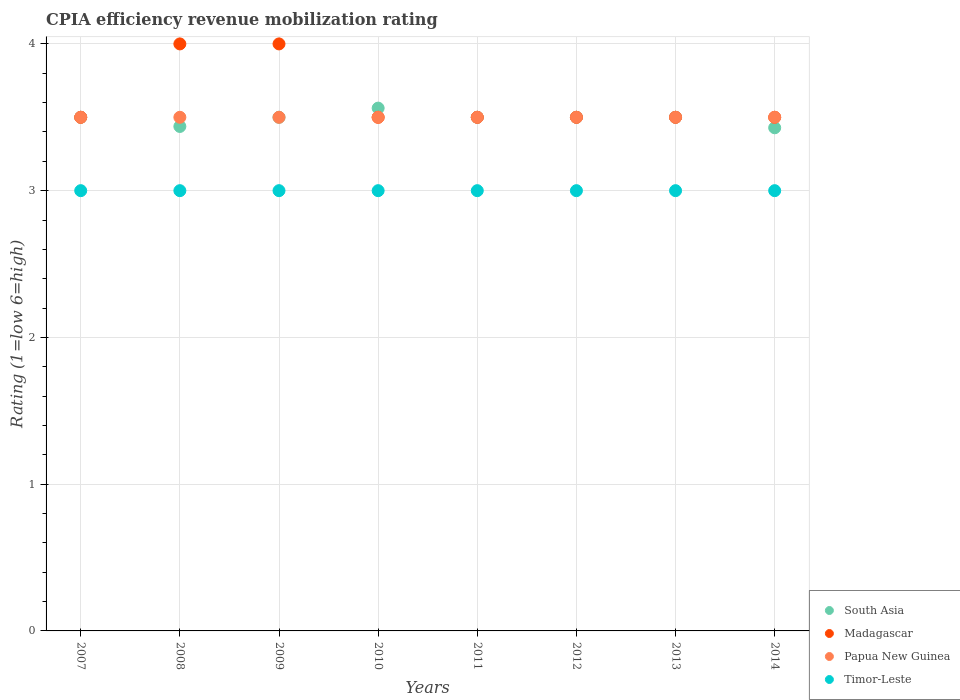What is the CPIA rating in Madagascar in 2010?
Offer a very short reply. 3.5. Across all years, what is the maximum CPIA rating in Timor-Leste?
Provide a short and direct response. 3. What is the total CPIA rating in South Asia in the graph?
Ensure brevity in your answer.  27.93. What is the difference between the CPIA rating in Madagascar in 2013 and the CPIA rating in Papua New Guinea in 2014?
Provide a short and direct response. 0. What is the average CPIA rating in Timor-Leste per year?
Your answer should be compact. 3. In how many years, is the CPIA rating in Timor-Leste greater than 1.6?
Give a very brief answer. 8. What is the ratio of the CPIA rating in South Asia in 2010 to that in 2014?
Your answer should be compact. 1.04. Is the CPIA rating in Papua New Guinea in 2007 less than that in 2010?
Your answer should be very brief. No. Is the difference between the CPIA rating in Papua New Guinea in 2009 and 2011 greater than the difference between the CPIA rating in Timor-Leste in 2009 and 2011?
Your answer should be very brief. No. What is the difference between the highest and the lowest CPIA rating in Madagascar?
Ensure brevity in your answer.  0.5. In how many years, is the CPIA rating in Timor-Leste greater than the average CPIA rating in Timor-Leste taken over all years?
Ensure brevity in your answer.  0. Is it the case that in every year, the sum of the CPIA rating in Papua New Guinea and CPIA rating in Madagascar  is greater than the sum of CPIA rating in South Asia and CPIA rating in Timor-Leste?
Keep it short and to the point. Yes. Is the CPIA rating in South Asia strictly less than the CPIA rating in Madagascar over the years?
Keep it short and to the point. No. How many dotlines are there?
Offer a terse response. 4. Does the graph contain grids?
Your answer should be very brief. Yes. How many legend labels are there?
Provide a succinct answer. 4. What is the title of the graph?
Offer a very short reply. CPIA efficiency revenue mobilization rating. What is the label or title of the X-axis?
Provide a short and direct response. Years. What is the Rating (1=low 6=high) in Papua New Guinea in 2007?
Your answer should be compact. 3.5. What is the Rating (1=low 6=high) in South Asia in 2008?
Offer a terse response. 3.44. What is the Rating (1=low 6=high) in Madagascar in 2008?
Provide a succinct answer. 4. What is the Rating (1=low 6=high) of South Asia in 2010?
Keep it short and to the point. 3.56. What is the Rating (1=low 6=high) in Timor-Leste in 2010?
Ensure brevity in your answer.  3. What is the Rating (1=low 6=high) in South Asia in 2011?
Make the answer very short. 3.5. What is the Rating (1=low 6=high) in Madagascar in 2011?
Make the answer very short. 3.5. What is the Rating (1=low 6=high) of Papua New Guinea in 2011?
Your answer should be very brief. 3.5. What is the Rating (1=low 6=high) in Timor-Leste in 2011?
Ensure brevity in your answer.  3. What is the Rating (1=low 6=high) of South Asia in 2012?
Offer a very short reply. 3.5. What is the Rating (1=low 6=high) of Papua New Guinea in 2012?
Give a very brief answer. 3.5. What is the Rating (1=low 6=high) of Timor-Leste in 2012?
Offer a terse response. 3. What is the Rating (1=low 6=high) of South Asia in 2013?
Ensure brevity in your answer.  3.5. What is the Rating (1=low 6=high) in Timor-Leste in 2013?
Your answer should be compact. 3. What is the Rating (1=low 6=high) in South Asia in 2014?
Provide a succinct answer. 3.43. What is the Rating (1=low 6=high) in Papua New Guinea in 2014?
Your answer should be very brief. 3.5. Across all years, what is the maximum Rating (1=low 6=high) of South Asia?
Keep it short and to the point. 3.56. Across all years, what is the minimum Rating (1=low 6=high) of South Asia?
Provide a short and direct response. 3.43. Across all years, what is the minimum Rating (1=low 6=high) of Papua New Guinea?
Provide a succinct answer. 3.5. What is the total Rating (1=low 6=high) of South Asia in the graph?
Keep it short and to the point. 27.93. What is the total Rating (1=low 6=high) in Papua New Guinea in the graph?
Provide a succinct answer. 28. What is the difference between the Rating (1=low 6=high) in South Asia in 2007 and that in 2008?
Provide a short and direct response. 0.06. What is the difference between the Rating (1=low 6=high) in Madagascar in 2007 and that in 2008?
Make the answer very short. -0.5. What is the difference between the Rating (1=low 6=high) of Timor-Leste in 2007 and that in 2008?
Provide a succinct answer. 0. What is the difference between the Rating (1=low 6=high) of Madagascar in 2007 and that in 2009?
Your response must be concise. -0.5. What is the difference between the Rating (1=low 6=high) of Papua New Guinea in 2007 and that in 2009?
Your answer should be very brief. 0. What is the difference between the Rating (1=low 6=high) in Timor-Leste in 2007 and that in 2009?
Make the answer very short. 0. What is the difference between the Rating (1=low 6=high) of South Asia in 2007 and that in 2010?
Your response must be concise. -0.06. What is the difference between the Rating (1=low 6=high) in Madagascar in 2007 and that in 2010?
Provide a succinct answer. 0. What is the difference between the Rating (1=low 6=high) in South Asia in 2007 and that in 2011?
Keep it short and to the point. 0. What is the difference between the Rating (1=low 6=high) in Madagascar in 2007 and that in 2011?
Give a very brief answer. 0. What is the difference between the Rating (1=low 6=high) in Madagascar in 2007 and that in 2012?
Keep it short and to the point. 0. What is the difference between the Rating (1=low 6=high) of Timor-Leste in 2007 and that in 2012?
Your answer should be compact. 0. What is the difference between the Rating (1=low 6=high) of Papua New Guinea in 2007 and that in 2013?
Offer a terse response. 0. What is the difference between the Rating (1=low 6=high) of Timor-Leste in 2007 and that in 2013?
Offer a terse response. 0. What is the difference between the Rating (1=low 6=high) in South Asia in 2007 and that in 2014?
Give a very brief answer. 0.07. What is the difference between the Rating (1=low 6=high) in Papua New Guinea in 2007 and that in 2014?
Your answer should be very brief. 0. What is the difference between the Rating (1=low 6=high) of South Asia in 2008 and that in 2009?
Your answer should be very brief. -0.06. What is the difference between the Rating (1=low 6=high) of Madagascar in 2008 and that in 2009?
Offer a very short reply. 0. What is the difference between the Rating (1=low 6=high) of South Asia in 2008 and that in 2010?
Provide a succinct answer. -0.12. What is the difference between the Rating (1=low 6=high) in Madagascar in 2008 and that in 2010?
Provide a succinct answer. 0.5. What is the difference between the Rating (1=low 6=high) of South Asia in 2008 and that in 2011?
Your answer should be compact. -0.06. What is the difference between the Rating (1=low 6=high) in Madagascar in 2008 and that in 2011?
Make the answer very short. 0.5. What is the difference between the Rating (1=low 6=high) in Papua New Guinea in 2008 and that in 2011?
Give a very brief answer. 0. What is the difference between the Rating (1=low 6=high) in South Asia in 2008 and that in 2012?
Make the answer very short. -0.06. What is the difference between the Rating (1=low 6=high) of Papua New Guinea in 2008 and that in 2012?
Provide a short and direct response. 0. What is the difference between the Rating (1=low 6=high) in South Asia in 2008 and that in 2013?
Your answer should be compact. -0.06. What is the difference between the Rating (1=low 6=high) in Papua New Guinea in 2008 and that in 2013?
Ensure brevity in your answer.  0. What is the difference between the Rating (1=low 6=high) of South Asia in 2008 and that in 2014?
Provide a short and direct response. 0.01. What is the difference between the Rating (1=low 6=high) in Madagascar in 2008 and that in 2014?
Offer a terse response. 0.5. What is the difference between the Rating (1=low 6=high) of Papua New Guinea in 2008 and that in 2014?
Offer a very short reply. 0. What is the difference between the Rating (1=low 6=high) of South Asia in 2009 and that in 2010?
Make the answer very short. -0.06. What is the difference between the Rating (1=low 6=high) in Madagascar in 2009 and that in 2010?
Offer a very short reply. 0.5. What is the difference between the Rating (1=low 6=high) in Madagascar in 2009 and that in 2011?
Provide a short and direct response. 0.5. What is the difference between the Rating (1=low 6=high) in Papua New Guinea in 2009 and that in 2012?
Make the answer very short. 0. What is the difference between the Rating (1=low 6=high) of Madagascar in 2009 and that in 2013?
Offer a very short reply. 0.5. What is the difference between the Rating (1=low 6=high) in Timor-Leste in 2009 and that in 2013?
Your answer should be very brief. 0. What is the difference between the Rating (1=low 6=high) in South Asia in 2009 and that in 2014?
Provide a succinct answer. 0.07. What is the difference between the Rating (1=low 6=high) of Madagascar in 2009 and that in 2014?
Your answer should be compact. 0.5. What is the difference between the Rating (1=low 6=high) of Papua New Guinea in 2009 and that in 2014?
Make the answer very short. 0. What is the difference between the Rating (1=low 6=high) of South Asia in 2010 and that in 2011?
Keep it short and to the point. 0.06. What is the difference between the Rating (1=low 6=high) in South Asia in 2010 and that in 2012?
Provide a short and direct response. 0.06. What is the difference between the Rating (1=low 6=high) of Madagascar in 2010 and that in 2012?
Offer a very short reply. 0. What is the difference between the Rating (1=low 6=high) of Timor-Leste in 2010 and that in 2012?
Your answer should be very brief. 0. What is the difference between the Rating (1=low 6=high) of South Asia in 2010 and that in 2013?
Give a very brief answer. 0.06. What is the difference between the Rating (1=low 6=high) in South Asia in 2010 and that in 2014?
Keep it short and to the point. 0.13. What is the difference between the Rating (1=low 6=high) of Papua New Guinea in 2010 and that in 2014?
Provide a short and direct response. 0. What is the difference between the Rating (1=low 6=high) in Timor-Leste in 2010 and that in 2014?
Provide a succinct answer. 0. What is the difference between the Rating (1=low 6=high) in Madagascar in 2011 and that in 2012?
Your answer should be compact. 0. What is the difference between the Rating (1=low 6=high) of Papua New Guinea in 2011 and that in 2012?
Provide a short and direct response. 0. What is the difference between the Rating (1=low 6=high) of Madagascar in 2011 and that in 2013?
Ensure brevity in your answer.  0. What is the difference between the Rating (1=low 6=high) in Timor-Leste in 2011 and that in 2013?
Offer a terse response. 0. What is the difference between the Rating (1=low 6=high) in South Asia in 2011 and that in 2014?
Provide a short and direct response. 0.07. What is the difference between the Rating (1=low 6=high) of Timor-Leste in 2011 and that in 2014?
Keep it short and to the point. 0. What is the difference between the Rating (1=low 6=high) in South Asia in 2012 and that in 2013?
Ensure brevity in your answer.  0. What is the difference between the Rating (1=low 6=high) in Madagascar in 2012 and that in 2013?
Offer a very short reply. 0. What is the difference between the Rating (1=low 6=high) of Papua New Guinea in 2012 and that in 2013?
Keep it short and to the point. 0. What is the difference between the Rating (1=low 6=high) in Timor-Leste in 2012 and that in 2013?
Make the answer very short. 0. What is the difference between the Rating (1=low 6=high) in South Asia in 2012 and that in 2014?
Your answer should be very brief. 0.07. What is the difference between the Rating (1=low 6=high) in Papua New Guinea in 2012 and that in 2014?
Your answer should be very brief. 0. What is the difference between the Rating (1=low 6=high) of Timor-Leste in 2012 and that in 2014?
Your answer should be very brief. 0. What is the difference between the Rating (1=low 6=high) in South Asia in 2013 and that in 2014?
Offer a very short reply. 0.07. What is the difference between the Rating (1=low 6=high) in Timor-Leste in 2013 and that in 2014?
Offer a terse response. 0. What is the difference between the Rating (1=low 6=high) in South Asia in 2007 and the Rating (1=low 6=high) in Madagascar in 2008?
Your response must be concise. -0.5. What is the difference between the Rating (1=low 6=high) of Madagascar in 2007 and the Rating (1=low 6=high) of Timor-Leste in 2008?
Your response must be concise. 0.5. What is the difference between the Rating (1=low 6=high) of South Asia in 2007 and the Rating (1=low 6=high) of Timor-Leste in 2009?
Your response must be concise. 0.5. What is the difference between the Rating (1=low 6=high) of Madagascar in 2007 and the Rating (1=low 6=high) of Papua New Guinea in 2009?
Offer a very short reply. 0. What is the difference between the Rating (1=low 6=high) of Madagascar in 2007 and the Rating (1=low 6=high) of Timor-Leste in 2009?
Ensure brevity in your answer.  0.5. What is the difference between the Rating (1=low 6=high) in South Asia in 2007 and the Rating (1=low 6=high) in Madagascar in 2010?
Provide a succinct answer. 0. What is the difference between the Rating (1=low 6=high) in South Asia in 2007 and the Rating (1=low 6=high) in Timor-Leste in 2010?
Provide a short and direct response. 0.5. What is the difference between the Rating (1=low 6=high) of Madagascar in 2007 and the Rating (1=low 6=high) of Timor-Leste in 2010?
Keep it short and to the point. 0.5. What is the difference between the Rating (1=low 6=high) in Papua New Guinea in 2007 and the Rating (1=low 6=high) in Timor-Leste in 2010?
Offer a very short reply. 0.5. What is the difference between the Rating (1=low 6=high) in Madagascar in 2007 and the Rating (1=low 6=high) in Papua New Guinea in 2011?
Give a very brief answer. 0. What is the difference between the Rating (1=low 6=high) in Papua New Guinea in 2007 and the Rating (1=low 6=high) in Timor-Leste in 2011?
Give a very brief answer. 0.5. What is the difference between the Rating (1=low 6=high) in South Asia in 2007 and the Rating (1=low 6=high) in Timor-Leste in 2012?
Provide a short and direct response. 0.5. What is the difference between the Rating (1=low 6=high) in Madagascar in 2007 and the Rating (1=low 6=high) in Papua New Guinea in 2012?
Your answer should be compact. 0. What is the difference between the Rating (1=low 6=high) in Madagascar in 2007 and the Rating (1=low 6=high) in Timor-Leste in 2012?
Your answer should be compact. 0.5. What is the difference between the Rating (1=low 6=high) of Papua New Guinea in 2007 and the Rating (1=low 6=high) of Timor-Leste in 2012?
Provide a short and direct response. 0.5. What is the difference between the Rating (1=low 6=high) of South Asia in 2007 and the Rating (1=low 6=high) of Papua New Guinea in 2013?
Your response must be concise. 0. What is the difference between the Rating (1=low 6=high) of Madagascar in 2007 and the Rating (1=low 6=high) of Papua New Guinea in 2013?
Ensure brevity in your answer.  0. What is the difference between the Rating (1=low 6=high) of Papua New Guinea in 2007 and the Rating (1=low 6=high) of Timor-Leste in 2013?
Provide a succinct answer. 0.5. What is the difference between the Rating (1=low 6=high) in South Asia in 2007 and the Rating (1=low 6=high) in Timor-Leste in 2014?
Ensure brevity in your answer.  0.5. What is the difference between the Rating (1=low 6=high) of Papua New Guinea in 2007 and the Rating (1=low 6=high) of Timor-Leste in 2014?
Provide a succinct answer. 0.5. What is the difference between the Rating (1=low 6=high) of South Asia in 2008 and the Rating (1=low 6=high) of Madagascar in 2009?
Ensure brevity in your answer.  -0.56. What is the difference between the Rating (1=low 6=high) of South Asia in 2008 and the Rating (1=low 6=high) of Papua New Guinea in 2009?
Provide a succinct answer. -0.06. What is the difference between the Rating (1=low 6=high) in South Asia in 2008 and the Rating (1=low 6=high) in Timor-Leste in 2009?
Give a very brief answer. 0.44. What is the difference between the Rating (1=low 6=high) in Madagascar in 2008 and the Rating (1=low 6=high) in Papua New Guinea in 2009?
Your response must be concise. 0.5. What is the difference between the Rating (1=low 6=high) of Madagascar in 2008 and the Rating (1=low 6=high) of Timor-Leste in 2009?
Your answer should be compact. 1. What is the difference between the Rating (1=low 6=high) in Papua New Guinea in 2008 and the Rating (1=low 6=high) in Timor-Leste in 2009?
Your answer should be very brief. 0.5. What is the difference between the Rating (1=low 6=high) of South Asia in 2008 and the Rating (1=low 6=high) of Madagascar in 2010?
Your answer should be very brief. -0.06. What is the difference between the Rating (1=low 6=high) in South Asia in 2008 and the Rating (1=low 6=high) in Papua New Guinea in 2010?
Provide a short and direct response. -0.06. What is the difference between the Rating (1=low 6=high) of South Asia in 2008 and the Rating (1=low 6=high) of Timor-Leste in 2010?
Offer a terse response. 0.44. What is the difference between the Rating (1=low 6=high) of Papua New Guinea in 2008 and the Rating (1=low 6=high) of Timor-Leste in 2010?
Provide a succinct answer. 0.5. What is the difference between the Rating (1=low 6=high) in South Asia in 2008 and the Rating (1=low 6=high) in Madagascar in 2011?
Keep it short and to the point. -0.06. What is the difference between the Rating (1=low 6=high) in South Asia in 2008 and the Rating (1=low 6=high) in Papua New Guinea in 2011?
Your response must be concise. -0.06. What is the difference between the Rating (1=low 6=high) of South Asia in 2008 and the Rating (1=low 6=high) of Timor-Leste in 2011?
Your response must be concise. 0.44. What is the difference between the Rating (1=low 6=high) in Madagascar in 2008 and the Rating (1=low 6=high) in Timor-Leste in 2011?
Offer a terse response. 1. What is the difference between the Rating (1=low 6=high) of Papua New Guinea in 2008 and the Rating (1=low 6=high) of Timor-Leste in 2011?
Give a very brief answer. 0.5. What is the difference between the Rating (1=low 6=high) in South Asia in 2008 and the Rating (1=low 6=high) in Madagascar in 2012?
Keep it short and to the point. -0.06. What is the difference between the Rating (1=low 6=high) of South Asia in 2008 and the Rating (1=low 6=high) of Papua New Guinea in 2012?
Make the answer very short. -0.06. What is the difference between the Rating (1=low 6=high) in South Asia in 2008 and the Rating (1=low 6=high) in Timor-Leste in 2012?
Make the answer very short. 0.44. What is the difference between the Rating (1=low 6=high) in Madagascar in 2008 and the Rating (1=low 6=high) in Papua New Guinea in 2012?
Ensure brevity in your answer.  0.5. What is the difference between the Rating (1=low 6=high) of Madagascar in 2008 and the Rating (1=low 6=high) of Timor-Leste in 2012?
Make the answer very short. 1. What is the difference between the Rating (1=low 6=high) in South Asia in 2008 and the Rating (1=low 6=high) in Madagascar in 2013?
Offer a terse response. -0.06. What is the difference between the Rating (1=low 6=high) of South Asia in 2008 and the Rating (1=low 6=high) of Papua New Guinea in 2013?
Provide a succinct answer. -0.06. What is the difference between the Rating (1=low 6=high) of South Asia in 2008 and the Rating (1=low 6=high) of Timor-Leste in 2013?
Make the answer very short. 0.44. What is the difference between the Rating (1=low 6=high) in Madagascar in 2008 and the Rating (1=low 6=high) in Timor-Leste in 2013?
Your response must be concise. 1. What is the difference between the Rating (1=low 6=high) of Papua New Guinea in 2008 and the Rating (1=low 6=high) of Timor-Leste in 2013?
Your response must be concise. 0.5. What is the difference between the Rating (1=low 6=high) in South Asia in 2008 and the Rating (1=low 6=high) in Madagascar in 2014?
Offer a terse response. -0.06. What is the difference between the Rating (1=low 6=high) in South Asia in 2008 and the Rating (1=low 6=high) in Papua New Guinea in 2014?
Your answer should be very brief. -0.06. What is the difference between the Rating (1=low 6=high) in South Asia in 2008 and the Rating (1=low 6=high) in Timor-Leste in 2014?
Your response must be concise. 0.44. What is the difference between the Rating (1=low 6=high) in Madagascar in 2008 and the Rating (1=low 6=high) in Timor-Leste in 2014?
Make the answer very short. 1. What is the difference between the Rating (1=low 6=high) of Papua New Guinea in 2008 and the Rating (1=low 6=high) of Timor-Leste in 2014?
Provide a succinct answer. 0.5. What is the difference between the Rating (1=low 6=high) of South Asia in 2009 and the Rating (1=low 6=high) of Madagascar in 2010?
Your answer should be very brief. 0. What is the difference between the Rating (1=low 6=high) in Madagascar in 2009 and the Rating (1=low 6=high) in Papua New Guinea in 2010?
Your response must be concise. 0.5. What is the difference between the Rating (1=low 6=high) in Madagascar in 2009 and the Rating (1=low 6=high) in Timor-Leste in 2010?
Offer a terse response. 1. What is the difference between the Rating (1=low 6=high) in Papua New Guinea in 2009 and the Rating (1=low 6=high) in Timor-Leste in 2010?
Keep it short and to the point. 0.5. What is the difference between the Rating (1=low 6=high) of South Asia in 2009 and the Rating (1=low 6=high) of Madagascar in 2011?
Make the answer very short. 0. What is the difference between the Rating (1=low 6=high) in South Asia in 2009 and the Rating (1=low 6=high) in Papua New Guinea in 2011?
Provide a short and direct response. 0. What is the difference between the Rating (1=low 6=high) of South Asia in 2009 and the Rating (1=low 6=high) of Madagascar in 2012?
Provide a short and direct response. 0. What is the difference between the Rating (1=low 6=high) of South Asia in 2009 and the Rating (1=low 6=high) of Papua New Guinea in 2012?
Provide a short and direct response. 0. What is the difference between the Rating (1=low 6=high) in South Asia in 2009 and the Rating (1=low 6=high) in Timor-Leste in 2012?
Your answer should be very brief. 0.5. What is the difference between the Rating (1=low 6=high) in Madagascar in 2009 and the Rating (1=low 6=high) in Timor-Leste in 2012?
Offer a terse response. 1. What is the difference between the Rating (1=low 6=high) of South Asia in 2009 and the Rating (1=low 6=high) of Papua New Guinea in 2013?
Your response must be concise. 0. What is the difference between the Rating (1=low 6=high) of South Asia in 2009 and the Rating (1=low 6=high) of Timor-Leste in 2013?
Make the answer very short. 0.5. What is the difference between the Rating (1=low 6=high) of Madagascar in 2009 and the Rating (1=low 6=high) of Papua New Guinea in 2013?
Provide a short and direct response. 0.5. What is the difference between the Rating (1=low 6=high) in Papua New Guinea in 2009 and the Rating (1=low 6=high) in Timor-Leste in 2013?
Your answer should be compact. 0.5. What is the difference between the Rating (1=low 6=high) in South Asia in 2010 and the Rating (1=low 6=high) in Madagascar in 2011?
Your answer should be compact. 0.06. What is the difference between the Rating (1=low 6=high) of South Asia in 2010 and the Rating (1=low 6=high) of Papua New Guinea in 2011?
Give a very brief answer. 0.06. What is the difference between the Rating (1=low 6=high) of South Asia in 2010 and the Rating (1=low 6=high) of Timor-Leste in 2011?
Keep it short and to the point. 0.56. What is the difference between the Rating (1=low 6=high) of Madagascar in 2010 and the Rating (1=low 6=high) of Papua New Guinea in 2011?
Your response must be concise. 0. What is the difference between the Rating (1=low 6=high) in Madagascar in 2010 and the Rating (1=low 6=high) in Timor-Leste in 2011?
Make the answer very short. 0.5. What is the difference between the Rating (1=low 6=high) in South Asia in 2010 and the Rating (1=low 6=high) in Madagascar in 2012?
Offer a very short reply. 0.06. What is the difference between the Rating (1=low 6=high) of South Asia in 2010 and the Rating (1=low 6=high) of Papua New Guinea in 2012?
Offer a very short reply. 0.06. What is the difference between the Rating (1=low 6=high) in South Asia in 2010 and the Rating (1=low 6=high) in Timor-Leste in 2012?
Keep it short and to the point. 0.56. What is the difference between the Rating (1=low 6=high) in Madagascar in 2010 and the Rating (1=low 6=high) in Papua New Guinea in 2012?
Provide a short and direct response. 0. What is the difference between the Rating (1=low 6=high) of South Asia in 2010 and the Rating (1=low 6=high) of Madagascar in 2013?
Ensure brevity in your answer.  0.06. What is the difference between the Rating (1=low 6=high) of South Asia in 2010 and the Rating (1=low 6=high) of Papua New Guinea in 2013?
Offer a terse response. 0.06. What is the difference between the Rating (1=low 6=high) of South Asia in 2010 and the Rating (1=low 6=high) of Timor-Leste in 2013?
Your answer should be very brief. 0.56. What is the difference between the Rating (1=low 6=high) in Madagascar in 2010 and the Rating (1=low 6=high) in Timor-Leste in 2013?
Your response must be concise. 0.5. What is the difference between the Rating (1=low 6=high) of Papua New Guinea in 2010 and the Rating (1=low 6=high) of Timor-Leste in 2013?
Your response must be concise. 0.5. What is the difference between the Rating (1=low 6=high) in South Asia in 2010 and the Rating (1=low 6=high) in Madagascar in 2014?
Provide a short and direct response. 0.06. What is the difference between the Rating (1=low 6=high) of South Asia in 2010 and the Rating (1=low 6=high) of Papua New Guinea in 2014?
Your answer should be compact. 0.06. What is the difference between the Rating (1=low 6=high) of South Asia in 2010 and the Rating (1=low 6=high) of Timor-Leste in 2014?
Your answer should be very brief. 0.56. What is the difference between the Rating (1=low 6=high) in Madagascar in 2010 and the Rating (1=low 6=high) in Papua New Guinea in 2014?
Offer a very short reply. 0. What is the difference between the Rating (1=low 6=high) in Madagascar in 2010 and the Rating (1=low 6=high) in Timor-Leste in 2014?
Your answer should be compact. 0.5. What is the difference between the Rating (1=low 6=high) in Papua New Guinea in 2010 and the Rating (1=low 6=high) in Timor-Leste in 2014?
Keep it short and to the point. 0.5. What is the difference between the Rating (1=low 6=high) in South Asia in 2011 and the Rating (1=low 6=high) in Timor-Leste in 2012?
Offer a terse response. 0.5. What is the difference between the Rating (1=low 6=high) of Madagascar in 2011 and the Rating (1=low 6=high) of Papua New Guinea in 2012?
Ensure brevity in your answer.  0. What is the difference between the Rating (1=low 6=high) in Madagascar in 2011 and the Rating (1=low 6=high) in Timor-Leste in 2012?
Give a very brief answer. 0.5. What is the difference between the Rating (1=low 6=high) of South Asia in 2011 and the Rating (1=low 6=high) of Madagascar in 2013?
Offer a very short reply. 0. What is the difference between the Rating (1=low 6=high) in Madagascar in 2011 and the Rating (1=low 6=high) in Timor-Leste in 2013?
Ensure brevity in your answer.  0.5. What is the difference between the Rating (1=low 6=high) in South Asia in 2011 and the Rating (1=low 6=high) in Madagascar in 2014?
Keep it short and to the point. 0. What is the difference between the Rating (1=low 6=high) in Madagascar in 2011 and the Rating (1=low 6=high) in Timor-Leste in 2014?
Make the answer very short. 0.5. What is the difference between the Rating (1=low 6=high) of South Asia in 2012 and the Rating (1=low 6=high) of Timor-Leste in 2013?
Give a very brief answer. 0.5. What is the difference between the Rating (1=low 6=high) of Madagascar in 2012 and the Rating (1=low 6=high) of Papua New Guinea in 2013?
Your response must be concise. 0. What is the difference between the Rating (1=low 6=high) of Madagascar in 2012 and the Rating (1=low 6=high) of Timor-Leste in 2013?
Ensure brevity in your answer.  0.5. What is the difference between the Rating (1=low 6=high) of Papua New Guinea in 2012 and the Rating (1=low 6=high) of Timor-Leste in 2013?
Offer a very short reply. 0.5. What is the difference between the Rating (1=low 6=high) of South Asia in 2012 and the Rating (1=low 6=high) of Timor-Leste in 2014?
Keep it short and to the point. 0.5. What is the difference between the Rating (1=low 6=high) in Papua New Guinea in 2012 and the Rating (1=low 6=high) in Timor-Leste in 2014?
Provide a succinct answer. 0.5. What is the difference between the Rating (1=low 6=high) in South Asia in 2013 and the Rating (1=low 6=high) in Timor-Leste in 2014?
Your response must be concise. 0.5. What is the difference between the Rating (1=low 6=high) in Madagascar in 2013 and the Rating (1=low 6=high) in Papua New Guinea in 2014?
Make the answer very short. 0. What is the average Rating (1=low 6=high) in South Asia per year?
Provide a succinct answer. 3.49. What is the average Rating (1=low 6=high) of Madagascar per year?
Give a very brief answer. 3.62. In the year 2007, what is the difference between the Rating (1=low 6=high) in South Asia and Rating (1=low 6=high) in Madagascar?
Give a very brief answer. 0. In the year 2007, what is the difference between the Rating (1=low 6=high) of South Asia and Rating (1=low 6=high) of Papua New Guinea?
Your answer should be very brief. 0. In the year 2008, what is the difference between the Rating (1=low 6=high) of South Asia and Rating (1=low 6=high) of Madagascar?
Give a very brief answer. -0.56. In the year 2008, what is the difference between the Rating (1=low 6=high) of South Asia and Rating (1=low 6=high) of Papua New Guinea?
Offer a very short reply. -0.06. In the year 2008, what is the difference between the Rating (1=low 6=high) of South Asia and Rating (1=low 6=high) of Timor-Leste?
Ensure brevity in your answer.  0.44. In the year 2008, what is the difference between the Rating (1=low 6=high) in Madagascar and Rating (1=low 6=high) in Papua New Guinea?
Provide a short and direct response. 0.5. In the year 2008, what is the difference between the Rating (1=low 6=high) in Madagascar and Rating (1=low 6=high) in Timor-Leste?
Keep it short and to the point. 1. In the year 2009, what is the difference between the Rating (1=low 6=high) of Madagascar and Rating (1=low 6=high) of Papua New Guinea?
Your answer should be compact. 0.5. In the year 2009, what is the difference between the Rating (1=low 6=high) of Papua New Guinea and Rating (1=low 6=high) of Timor-Leste?
Provide a short and direct response. 0.5. In the year 2010, what is the difference between the Rating (1=low 6=high) of South Asia and Rating (1=low 6=high) of Madagascar?
Keep it short and to the point. 0.06. In the year 2010, what is the difference between the Rating (1=low 6=high) in South Asia and Rating (1=low 6=high) in Papua New Guinea?
Offer a terse response. 0.06. In the year 2010, what is the difference between the Rating (1=low 6=high) in South Asia and Rating (1=low 6=high) in Timor-Leste?
Your response must be concise. 0.56. In the year 2010, what is the difference between the Rating (1=low 6=high) in Madagascar and Rating (1=low 6=high) in Papua New Guinea?
Give a very brief answer. 0. In the year 2010, what is the difference between the Rating (1=low 6=high) in Madagascar and Rating (1=low 6=high) in Timor-Leste?
Your answer should be very brief. 0.5. In the year 2011, what is the difference between the Rating (1=low 6=high) in South Asia and Rating (1=low 6=high) in Timor-Leste?
Offer a very short reply. 0.5. In the year 2012, what is the difference between the Rating (1=low 6=high) in South Asia and Rating (1=low 6=high) in Madagascar?
Ensure brevity in your answer.  0. In the year 2012, what is the difference between the Rating (1=low 6=high) of South Asia and Rating (1=low 6=high) of Timor-Leste?
Keep it short and to the point. 0.5. In the year 2012, what is the difference between the Rating (1=low 6=high) of Madagascar and Rating (1=low 6=high) of Papua New Guinea?
Your answer should be very brief. 0. In the year 2012, what is the difference between the Rating (1=low 6=high) in Papua New Guinea and Rating (1=low 6=high) in Timor-Leste?
Ensure brevity in your answer.  0.5. In the year 2013, what is the difference between the Rating (1=low 6=high) of South Asia and Rating (1=low 6=high) of Papua New Guinea?
Offer a terse response. 0. In the year 2014, what is the difference between the Rating (1=low 6=high) in South Asia and Rating (1=low 6=high) in Madagascar?
Offer a terse response. -0.07. In the year 2014, what is the difference between the Rating (1=low 6=high) in South Asia and Rating (1=low 6=high) in Papua New Guinea?
Give a very brief answer. -0.07. In the year 2014, what is the difference between the Rating (1=low 6=high) in South Asia and Rating (1=low 6=high) in Timor-Leste?
Make the answer very short. 0.43. In the year 2014, what is the difference between the Rating (1=low 6=high) of Madagascar and Rating (1=low 6=high) of Papua New Guinea?
Provide a short and direct response. 0. In the year 2014, what is the difference between the Rating (1=low 6=high) of Papua New Guinea and Rating (1=low 6=high) of Timor-Leste?
Ensure brevity in your answer.  0.5. What is the ratio of the Rating (1=low 6=high) of South Asia in 2007 to that in 2008?
Offer a terse response. 1.02. What is the ratio of the Rating (1=low 6=high) of Timor-Leste in 2007 to that in 2008?
Provide a succinct answer. 1. What is the ratio of the Rating (1=low 6=high) of South Asia in 2007 to that in 2009?
Provide a short and direct response. 1. What is the ratio of the Rating (1=low 6=high) of Madagascar in 2007 to that in 2009?
Offer a terse response. 0.88. What is the ratio of the Rating (1=low 6=high) in Papua New Guinea in 2007 to that in 2009?
Offer a terse response. 1. What is the ratio of the Rating (1=low 6=high) of Timor-Leste in 2007 to that in 2009?
Provide a succinct answer. 1. What is the ratio of the Rating (1=low 6=high) in South Asia in 2007 to that in 2010?
Your answer should be compact. 0.98. What is the ratio of the Rating (1=low 6=high) in Madagascar in 2007 to that in 2010?
Your answer should be very brief. 1. What is the ratio of the Rating (1=low 6=high) in Papua New Guinea in 2007 to that in 2010?
Ensure brevity in your answer.  1. What is the ratio of the Rating (1=low 6=high) of Timor-Leste in 2007 to that in 2010?
Give a very brief answer. 1. What is the ratio of the Rating (1=low 6=high) in South Asia in 2007 to that in 2011?
Ensure brevity in your answer.  1. What is the ratio of the Rating (1=low 6=high) in Madagascar in 2007 to that in 2011?
Make the answer very short. 1. What is the ratio of the Rating (1=low 6=high) of Timor-Leste in 2007 to that in 2011?
Make the answer very short. 1. What is the ratio of the Rating (1=low 6=high) in South Asia in 2007 to that in 2012?
Offer a very short reply. 1. What is the ratio of the Rating (1=low 6=high) of Timor-Leste in 2007 to that in 2012?
Keep it short and to the point. 1. What is the ratio of the Rating (1=low 6=high) of Papua New Guinea in 2007 to that in 2013?
Your answer should be very brief. 1. What is the ratio of the Rating (1=low 6=high) in South Asia in 2007 to that in 2014?
Keep it short and to the point. 1.02. What is the ratio of the Rating (1=low 6=high) of South Asia in 2008 to that in 2009?
Ensure brevity in your answer.  0.98. What is the ratio of the Rating (1=low 6=high) of Madagascar in 2008 to that in 2009?
Make the answer very short. 1. What is the ratio of the Rating (1=low 6=high) in Papua New Guinea in 2008 to that in 2009?
Your response must be concise. 1. What is the ratio of the Rating (1=low 6=high) of South Asia in 2008 to that in 2010?
Make the answer very short. 0.96. What is the ratio of the Rating (1=low 6=high) of Papua New Guinea in 2008 to that in 2010?
Make the answer very short. 1. What is the ratio of the Rating (1=low 6=high) in Timor-Leste in 2008 to that in 2010?
Offer a terse response. 1. What is the ratio of the Rating (1=low 6=high) of South Asia in 2008 to that in 2011?
Provide a short and direct response. 0.98. What is the ratio of the Rating (1=low 6=high) in Madagascar in 2008 to that in 2011?
Your answer should be compact. 1.14. What is the ratio of the Rating (1=low 6=high) in Papua New Guinea in 2008 to that in 2011?
Offer a very short reply. 1. What is the ratio of the Rating (1=low 6=high) of South Asia in 2008 to that in 2012?
Give a very brief answer. 0.98. What is the ratio of the Rating (1=low 6=high) of Madagascar in 2008 to that in 2012?
Give a very brief answer. 1.14. What is the ratio of the Rating (1=low 6=high) in Papua New Guinea in 2008 to that in 2012?
Offer a very short reply. 1. What is the ratio of the Rating (1=low 6=high) in South Asia in 2008 to that in 2013?
Offer a very short reply. 0.98. What is the ratio of the Rating (1=low 6=high) of Papua New Guinea in 2008 to that in 2013?
Provide a succinct answer. 1. What is the ratio of the Rating (1=low 6=high) in Timor-Leste in 2008 to that in 2013?
Ensure brevity in your answer.  1. What is the ratio of the Rating (1=low 6=high) in South Asia in 2008 to that in 2014?
Provide a short and direct response. 1. What is the ratio of the Rating (1=low 6=high) of Madagascar in 2008 to that in 2014?
Your answer should be very brief. 1.14. What is the ratio of the Rating (1=low 6=high) in Papua New Guinea in 2008 to that in 2014?
Keep it short and to the point. 1. What is the ratio of the Rating (1=low 6=high) in South Asia in 2009 to that in 2010?
Provide a short and direct response. 0.98. What is the ratio of the Rating (1=low 6=high) in Madagascar in 2009 to that in 2010?
Your response must be concise. 1.14. What is the ratio of the Rating (1=low 6=high) in South Asia in 2009 to that in 2011?
Offer a terse response. 1. What is the ratio of the Rating (1=low 6=high) in Madagascar in 2009 to that in 2011?
Give a very brief answer. 1.14. What is the ratio of the Rating (1=low 6=high) in Timor-Leste in 2009 to that in 2011?
Keep it short and to the point. 1. What is the ratio of the Rating (1=low 6=high) of South Asia in 2009 to that in 2012?
Your response must be concise. 1. What is the ratio of the Rating (1=low 6=high) of Madagascar in 2009 to that in 2012?
Provide a succinct answer. 1.14. What is the ratio of the Rating (1=low 6=high) in Timor-Leste in 2009 to that in 2012?
Ensure brevity in your answer.  1. What is the ratio of the Rating (1=low 6=high) of South Asia in 2009 to that in 2014?
Your answer should be compact. 1.02. What is the ratio of the Rating (1=low 6=high) of Timor-Leste in 2009 to that in 2014?
Provide a succinct answer. 1. What is the ratio of the Rating (1=low 6=high) of South Asia in 2010 to that in 2011?
Provide a succinct answer. 1.02. What is the ratio of the Rating (1=low 6=high) of Papua New Guinea in 2010 to that in 2011?
Offer a very short reply. 1. What is the ratio of the Rating (1=low 6=high) of South Asia in 2010 to that in 2012?
Give a very brief answer. 1.02. What is the ratio of the Rating (1=low 6=high) in Papua New Guinea in 2010 to that in 2012?
Your response must be concise. 1. What is the ratio of the Rating (1=low 6=high) of South Asia in 2010 to that in 2013?
Make the answer very short. 1.02. What is the ratio of the Rating (1=low 6=high) of Madagascar in 2010 to that in 2013?
Offer a very short reply. 1. What is the ratio of the Rating (1=low 6=high) of Timor-Leste in 2010 to that in 2013?
Ensure brevity in your answer.  1. What is the ratio of the Rating (1=low 6=high) of South Asia in 2010 to that in 2014?
Offer a very short reply. 1.04. What is the ratio of the Rating (1=low 6=high) of Madagascar in 2010 to that in 2014?
Give a very brief answer. 1. What is the ratio of the Rating (1=low 6=high) of Papua New Guinea in 2010 to that in 2014?
Provide a succinct answer. 1. What is the ratio of the Rating (1=low 6=high) in South Asia in 2011 to that in 2012?
Make the answer very short. 1. What is the ratio of the Rating (1=low 6=high) of Papua New Guinea in 2011 to that in 2012?
Offer a very short reply. 1. What is the ratio of the Rating (1=low 6=high) in Papua New Guinea in 2011 to that in 2013?
Your answer should be very brief. 1. What is the ratio of the Rating (1=low 6=high) of Timor-Leste in 2011 to that in 2013?
Make the answer very short. 1. What is the ratio of the Rating (1=low 6=high) of South Asia in 2011 to that in 2014?
Offer a terse response. 1.02. What is the ratio of the Rating (1=low 6=high) of Papua New Guinea in 2011 to that in 2014?
Offer a terse response. 1. What is the ratio of the Rating (1=low 6=high) in Timor-Leste in 2012 to that in 2013?
Keep it short and to the point. 1. What is the ratio of the Rating (1=low 6=high) in South Asia in 2012 to that in 2014?
Provide a succinct answer. 1.02. What is the ratio of the Rating (1=low 6=high) of Papua New Guinea in 2012 to that in 2014?
Offer a terse response. 1. What is the ratio of the Rating (1=low 6=high) of Timor-Leste in 2012 to that in 2014?
Provide a short and direct response. 1. What is the ratio of the Rating (1=low 6=high) in South Asia in 2013 to that in 2014?
Provide a short and direct response. 1.02. What is the ratio of the Rating (1=low 6=high) of Madagascar in 2013 to that in 2014?
Your answer should be compact. 1. What is the difference between the highest and the second highest Rating (1=low 6=high) of South Asia?
Ensure brevity in your answer.  0.06. What is the difference between the highest and the second highest Rating (1=low 6=high) of Madagascar?
Give a very brief answer. 0. What is the difference between the highest and the lowest Rating (1=low 6=high) of South Asia?
Give a very brief answer. 0.13. What is the difference between the highest and the lowest Rating (1=low 6=high) in Timor-Leste?
Provide a short and direct response. 0. 